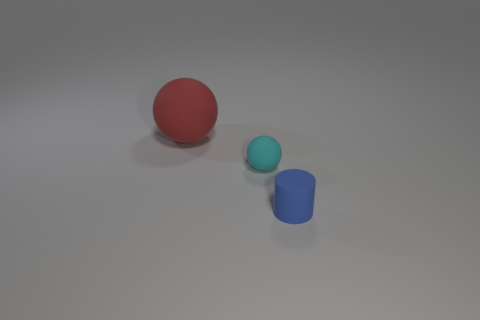Is the number of tiny blue cylinders that are in front of the blue cylinder the same as the number of small balls that are on the right side of the cyan thing?
Give a very brief answer. Yes. What is the color of the small object that is behind the small rubber object that is right of the sphere in front of the big matte ball?
Give a very brief answer. Cyan. What shape is the small thing that is behind the tiny cylinder?
Offer a terse response. Sphere. There is a red thing that is the same material as the blue object; what shape is it?
Make the answer very short. Sphere. Is there any other thing that has the same shape as the red thing?
Make the answer very short. Yes. There is a small rubber cylinder; how many tiny rubber things are behind it?
Your response must be concise. 1. Are there the same number of blue objects that are on the right side of the tiny blue cylinder and large red rubber objects?
Keep it short and to the point. No. Do the tiny cyan object and the cylinder have the same material?
Your response must be concise. Yes. There is a rubber thing that is in front of the red matte thing and on the left side of the tiny blue thing; what size is it?
Keep it short and to the point. Small. What number of other rubber objects are the same size as the blue matte thing?
Offer a very short reply. 1. 